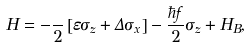<formula> <loc_0><loc_0><loc_500><loc_500>H = - \frac { } { 2 } \left [ \varepsilon \sigma _ { z } + \Delta \sigma _ { x } \right ] - \frac { \hbar { f } } { 2 } \sigma _ { z } + H _ { B } ,</formula> 